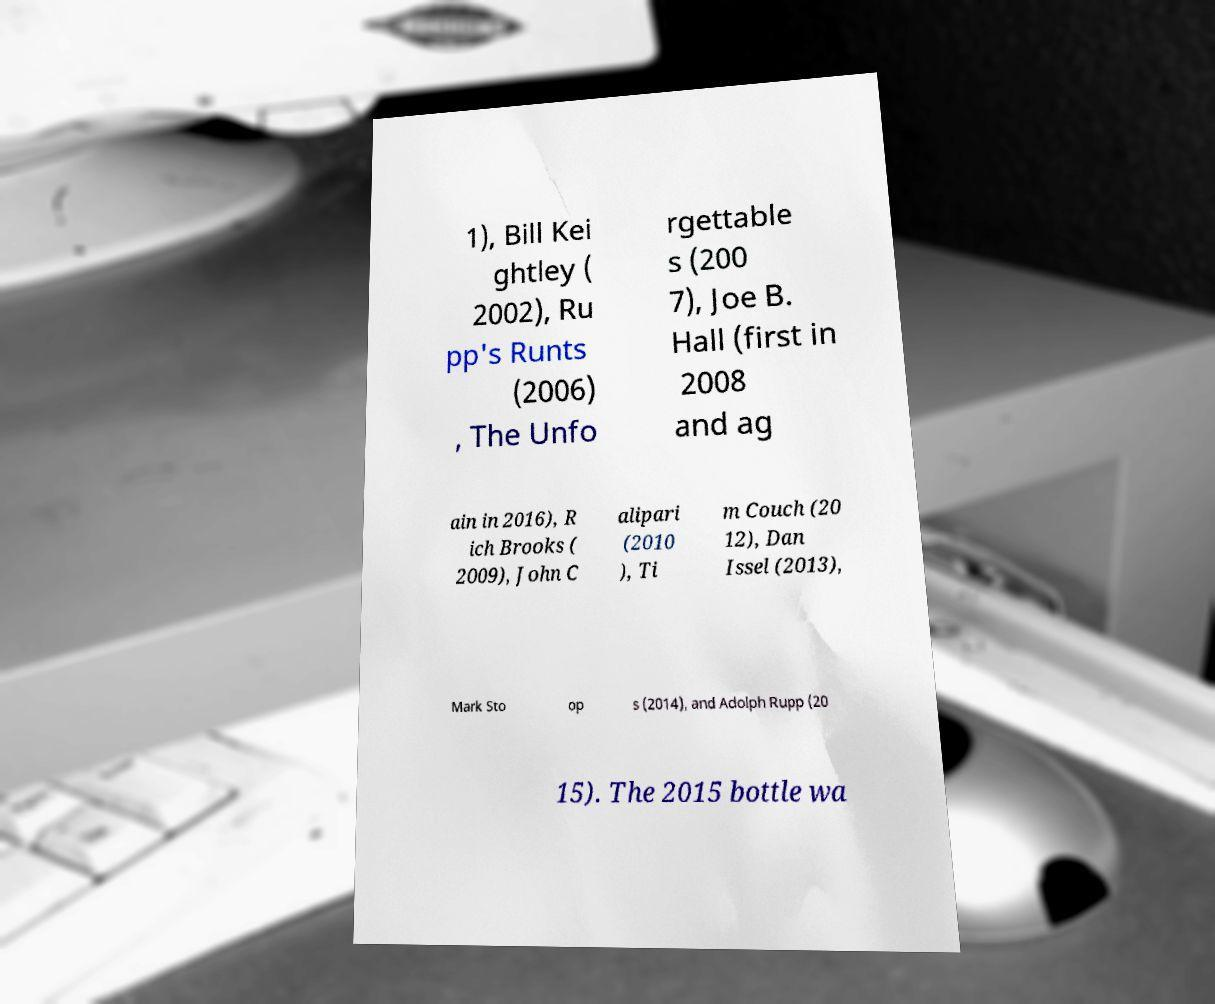Please identify and transcribe the text found in this image. 1), Bill Kei ghtley ( 2002), Ru pp's Runts (2006) , The Unfo rgettable s (200 7), Joe B. Hall (first in 2008 and ag ain in 2016), R ich Brooks ( 2009), John C alipari (2010 ), Ti m Couch (20 12), Dan Issel (2013), Mark Sto op s (2014), and Adolph Rupp (20 15). The 2015 bottle wa 